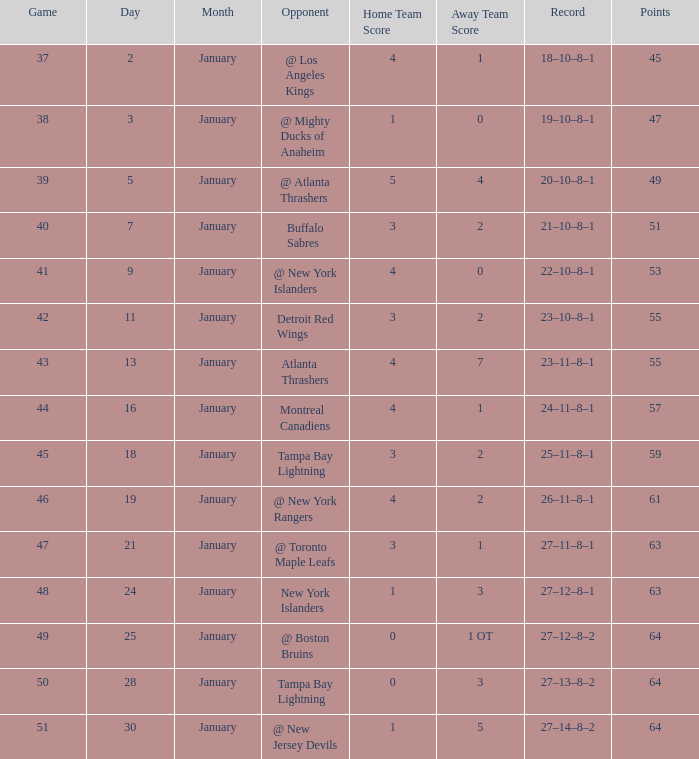Which score comprises 64 points and features a 49 game? 0–1 OT. 